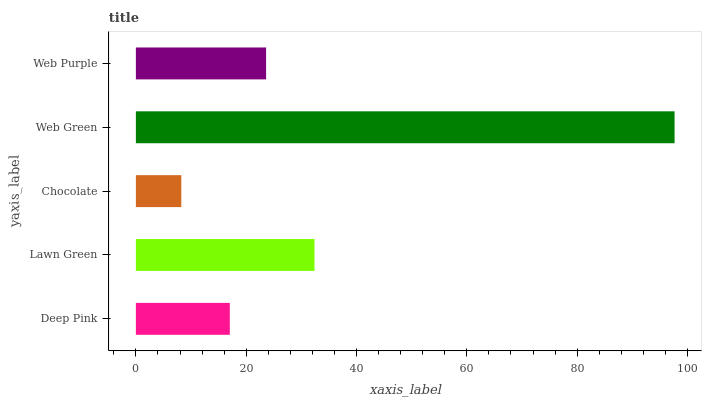Is Chocolate the minimum?
Answer yes or no. Yes. Is Web Green the maximum?
Answer yes or no. Yes. Is Lawn Green the minimum?
Answer yes or no. No. Is Lawn Green the maximum?
Answer yes or no. No. Is Lawn Green greater than Deep Pink?
Answer yes or no. Yes. Is Deep Pink less than Lawn Green?
Answer yes or no. Yes. Is Deep Pink greater than Lawn Green?
Answer yes or no. No. Is Lawn Green less than Deep Pink?
Answer yes or no. No. Is Web Purple the high median?
Answer yes or no. Yes. Is Web Purple the low median?
Answer yes or no. Yes. Is Lawn Green the high median?
Answer yes or no. No. Is Web Green the low median?
Answer yes or no. No. 